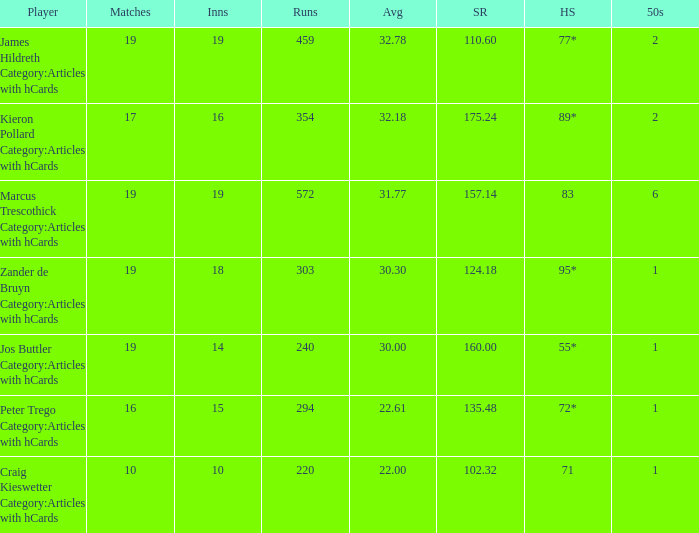What is the highest score for the player with average of 30.00? 55*. 